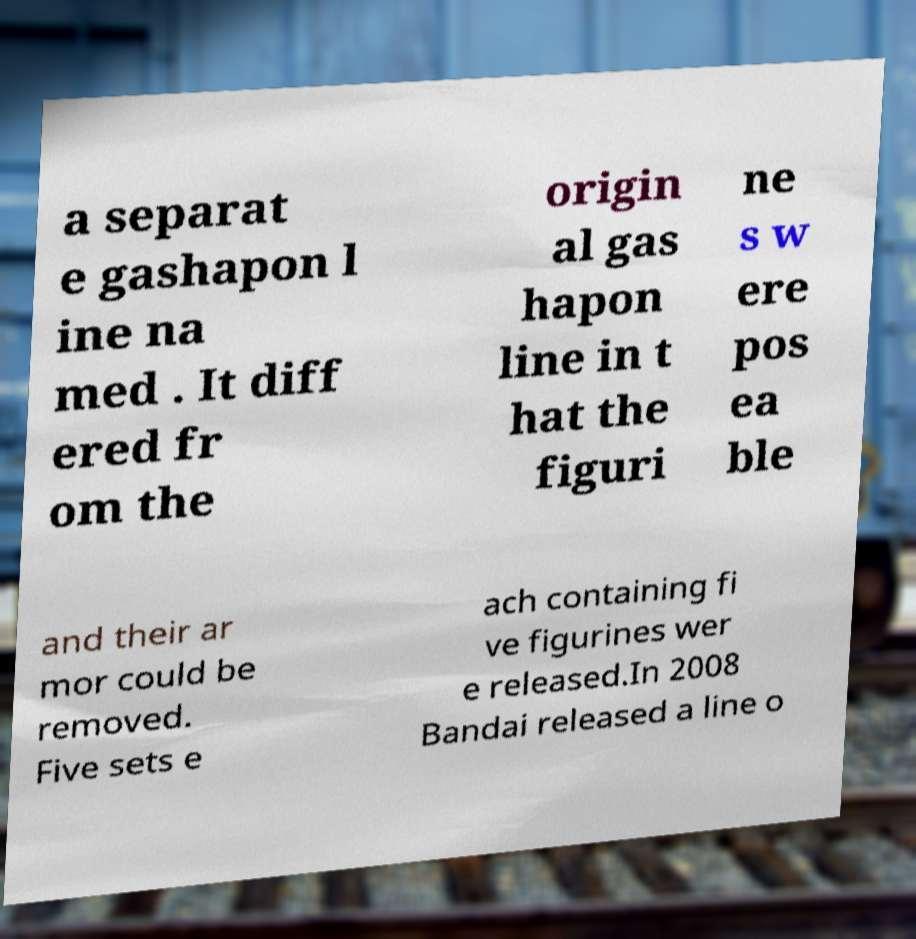Could you extract and type out the text from this image? a separat e gashapon l ine na med . It diff ered fr om the origin al gas hapon line in t hat the figuri ne s w ere pos ea ble and their ar mor could be removed. Five sets e ach containing fi ve figurines wer e released.In 2008 Bandai released a line o 